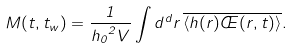Convert formula to latex. <formula><loc_0><loc_0><loc_500><loc_500>M ( t , t _ { w } ) = \frac { 1 } { { h _ { 0 } } ^ { 2 } V } \int \nolimits d ^ { d } r \, \overline { \langle h ( r ) \phi ( r , t ) \rangle } .</formula> 